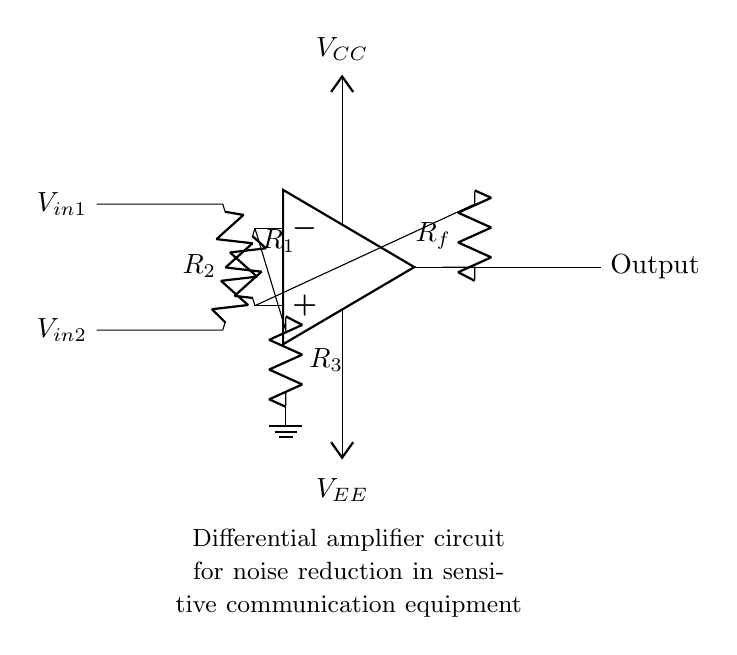What is the configuration of the amplifier? The amplifier is configured as a differential amplifier, which amplifies the voltage difference between two input signals.
Answer: Differential amplifier How many input resistors are present in this circuit? The circuit has two input resistors, which are connected to the non-inverting and inverting terminals of the op-amp.
Answer: Two What are the value labels for the feedback resistor? The feedback resistor is labeled as Rf, which indicates its role in providing feedback from the output to the inverting input terminal of the op-amp.
Answer: Rf What is the purpose of the ground in this circuit? The ground serves as a reference point for the voltage levels in the circuit, allowing the proper function of the amplifier by maintaining a stable reference voltage.
Answer: Reference point What types of noise reduction methods does a differential amplifier utilize? A differential amplifier reduces noise by amplifying only the difference between the input signals, effectively canceling out any noise that is common to both signals.
Answer: Common-mode rejection What is the significance of the power supply voltages in this circuit? The power supply voltages, Vcc and Vee, are essential for providing the necessary operating voltages for the op-amp, allowing it to function correctly and amplify signals.
Answer: Operating voltages What is the output relationship to the input signals? The output of a differential amplifier is proportional to the difference between the two input voltage signals, amplified by the circuit’s gain.
Answer: Difference amplification 